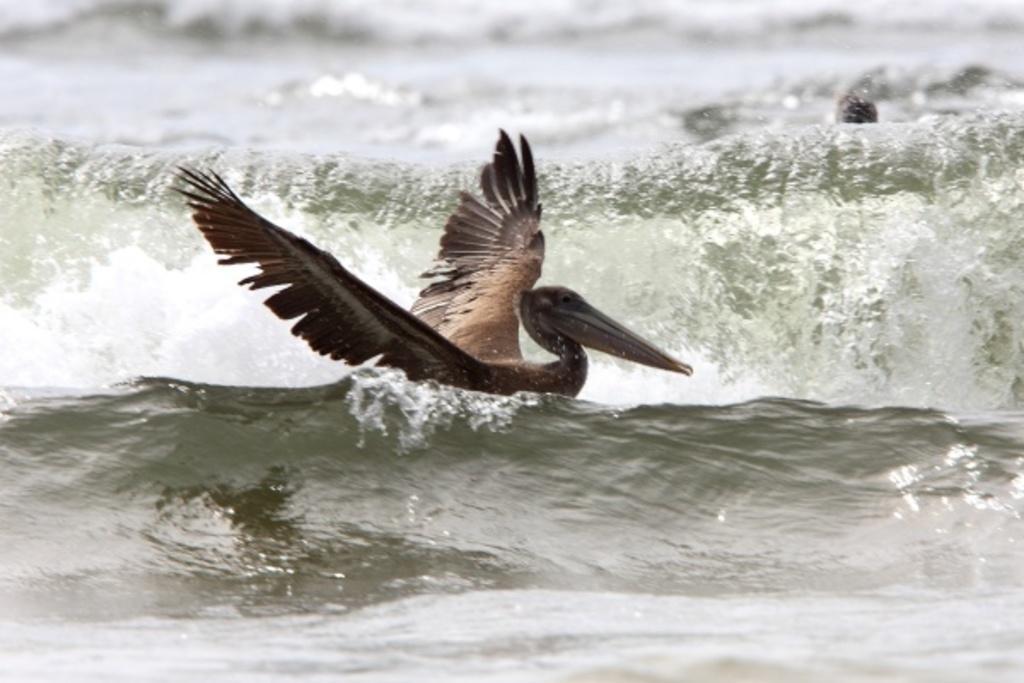Describe this image in one or two sentences. There is a mallard bird on the water. 